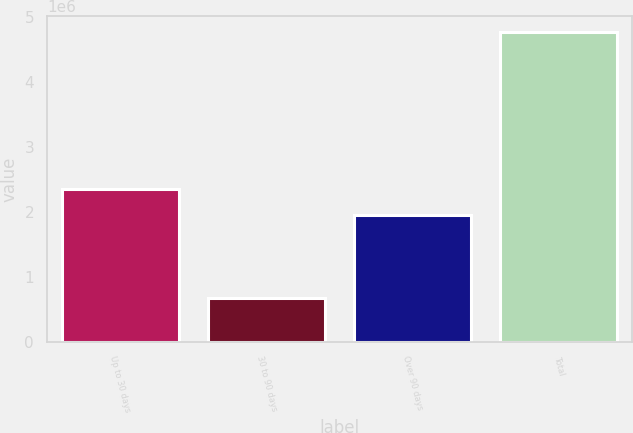<chart> <loc_0><loc_0><loc_500><loc_500><bar_chart><fcel>Up to 30 days<fcel>30 to 90 days<fcel>Over 90 days<fcel>Total<nl><fcel>2.3534e+06<fcel>676224<fcel>1.94414e+06<fcel>4.76882e+06<nl></chart> 